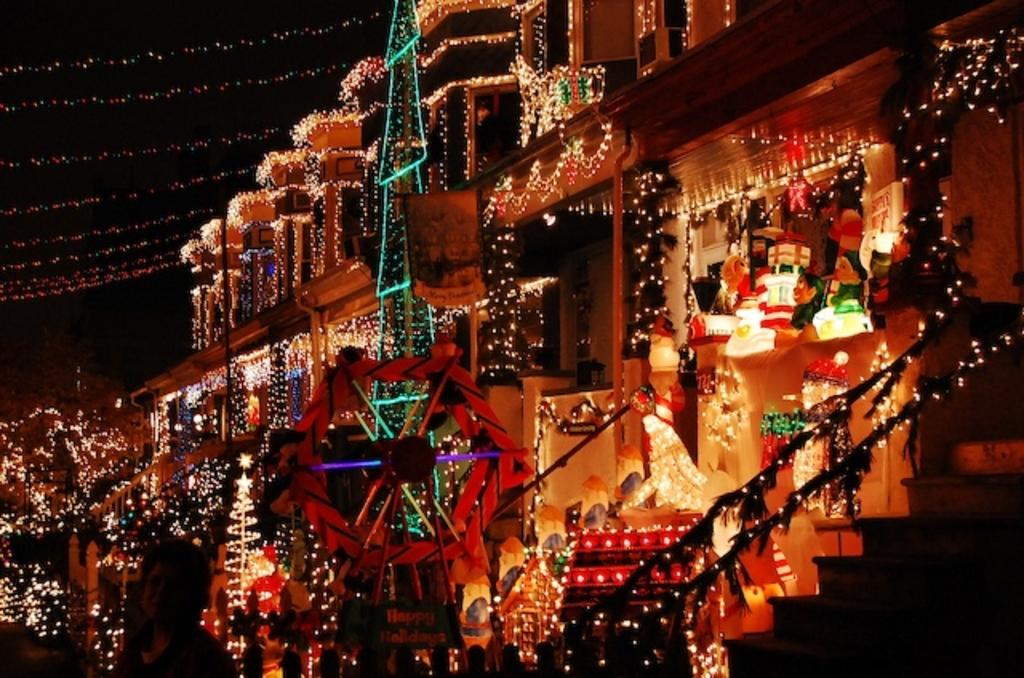What type of structure is present in the image? There is a building in the image. What can be seen illuminated in the image? There are lights visible in the image. What seasonal decoration is present in the image? There is an x-mas tree in the image. What architectural feature is present in the building? There is a staircase in the image. What is visible in the background of the image? The sky is visible in the image. What type of metal is used to create the canvas in the image? There is no canvas or metal present in the image. How does the water flow around the building in the image? There is no water present in the image; it is a building with lights, an x-mas tree, and a staircase. 